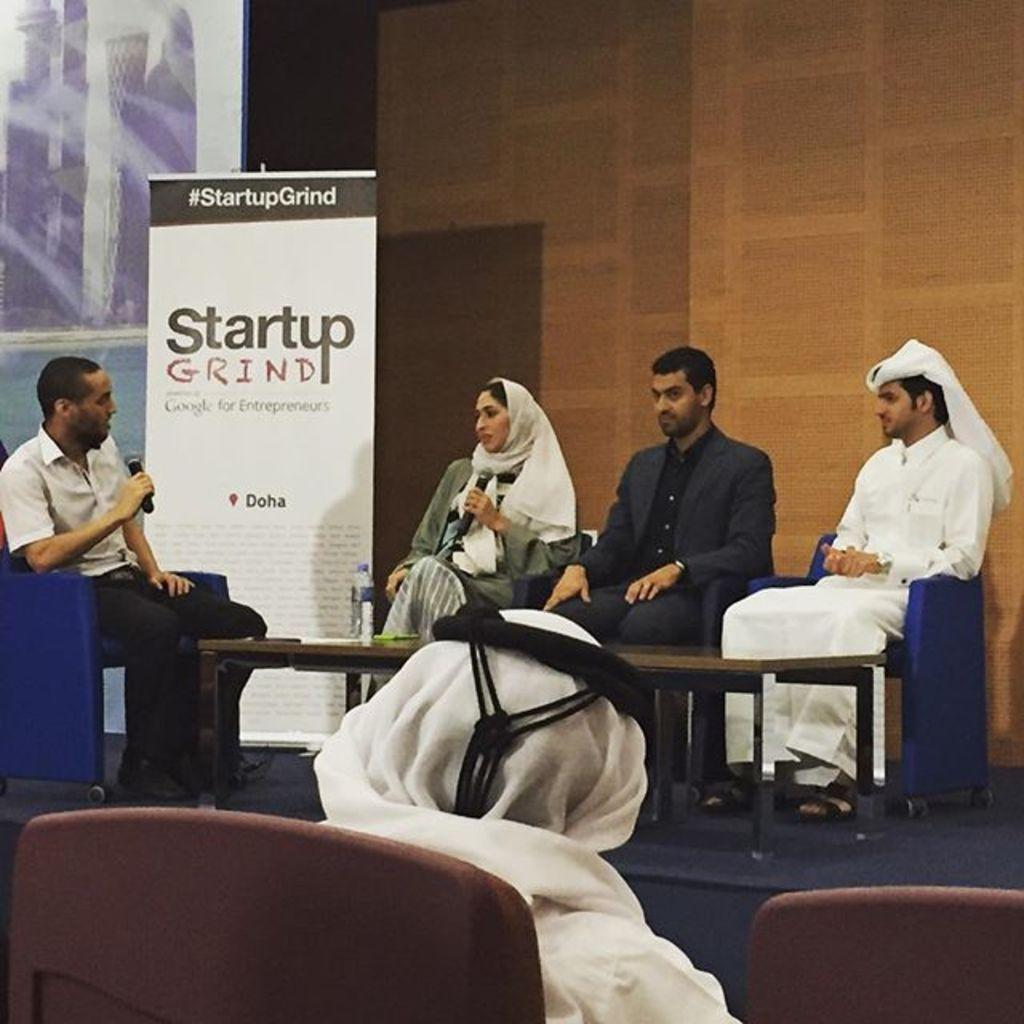What is on the stage in the image? There is a board on the stage. How many people are sitting on chairs in the image? There are five persons sitting on chairs. What is in front of the stage? There is a table in front of the stage. What can be seen on the table? There is a bottle on the table. What type of cushion is being rubbed by the persons sitting on chairs? There is no cushion present in the image, and the persons sitting on chairs are not rubbing anything. 